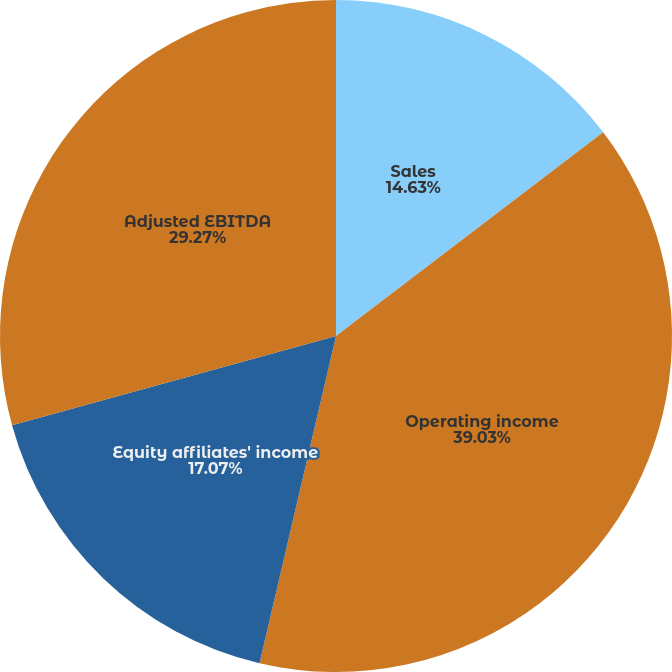<chart> <loc_0><loc_0><loc_500><loc_500><pie_chart><fcel>Sales<fcel>Operating income<fcel>Equity affiliates' income<fcel>Adjusted EBITDA<nl><fcel>14.63%<fcel>39.02%<fcel>17.07%<fcel>29.27%<nl></chart> 